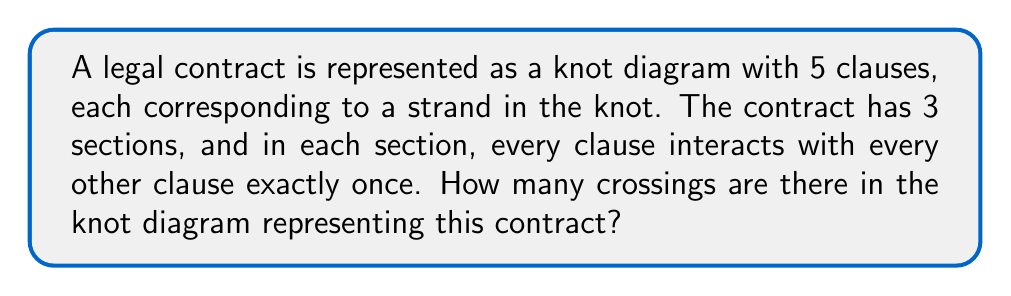Give your solution to this math problem. Let's approach this step-by-step:

1) First, we need to understand what each interaction represents in the knot diagram. Each interaction between two clauses corresponds to a crossing in the knot diagram.

2) We have 5 clauses, and in each section, every clause interacts with every other clause once. This is similar to the handshake problem in combinatorics.

3) For each section, the number of interactions (crossings) is equal to the number of ways to choose 2 clauses from 5, which is given by the combination formula:

   $$\binom{5}{2} = \frac{5!}{2!(5-2)!} = \frac{5 \cdot 4}{2 \cdot 1} = 10$$

4) Since there are 3 sections, and each section has 10 crossings, the total number of crossings is:

   $$3 \cdot 10 = 30$$

This representation as a knot diagram allows lawyers to visualize the complexity of the contract, where each crossing represents a potential point of negotiation or conflict between clauses.
Answer: 30 crossings 